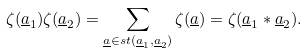<formula> <loc_0><loc_0><loc_500><loc_500>\zeta ( \underline { a } _ { 1 } ) \zeta ( \underline { a } _ { 2 } ) = \sum _ { \underline { a } \in s t ( \underline { a } _ { 1 } , \underline { a } _ { 2 } ) } \zeta ( \underline { a } ) = \zeta ( \underline { a } _ { 1 } * \underline { a } _ { 2 } ) .</formula> 